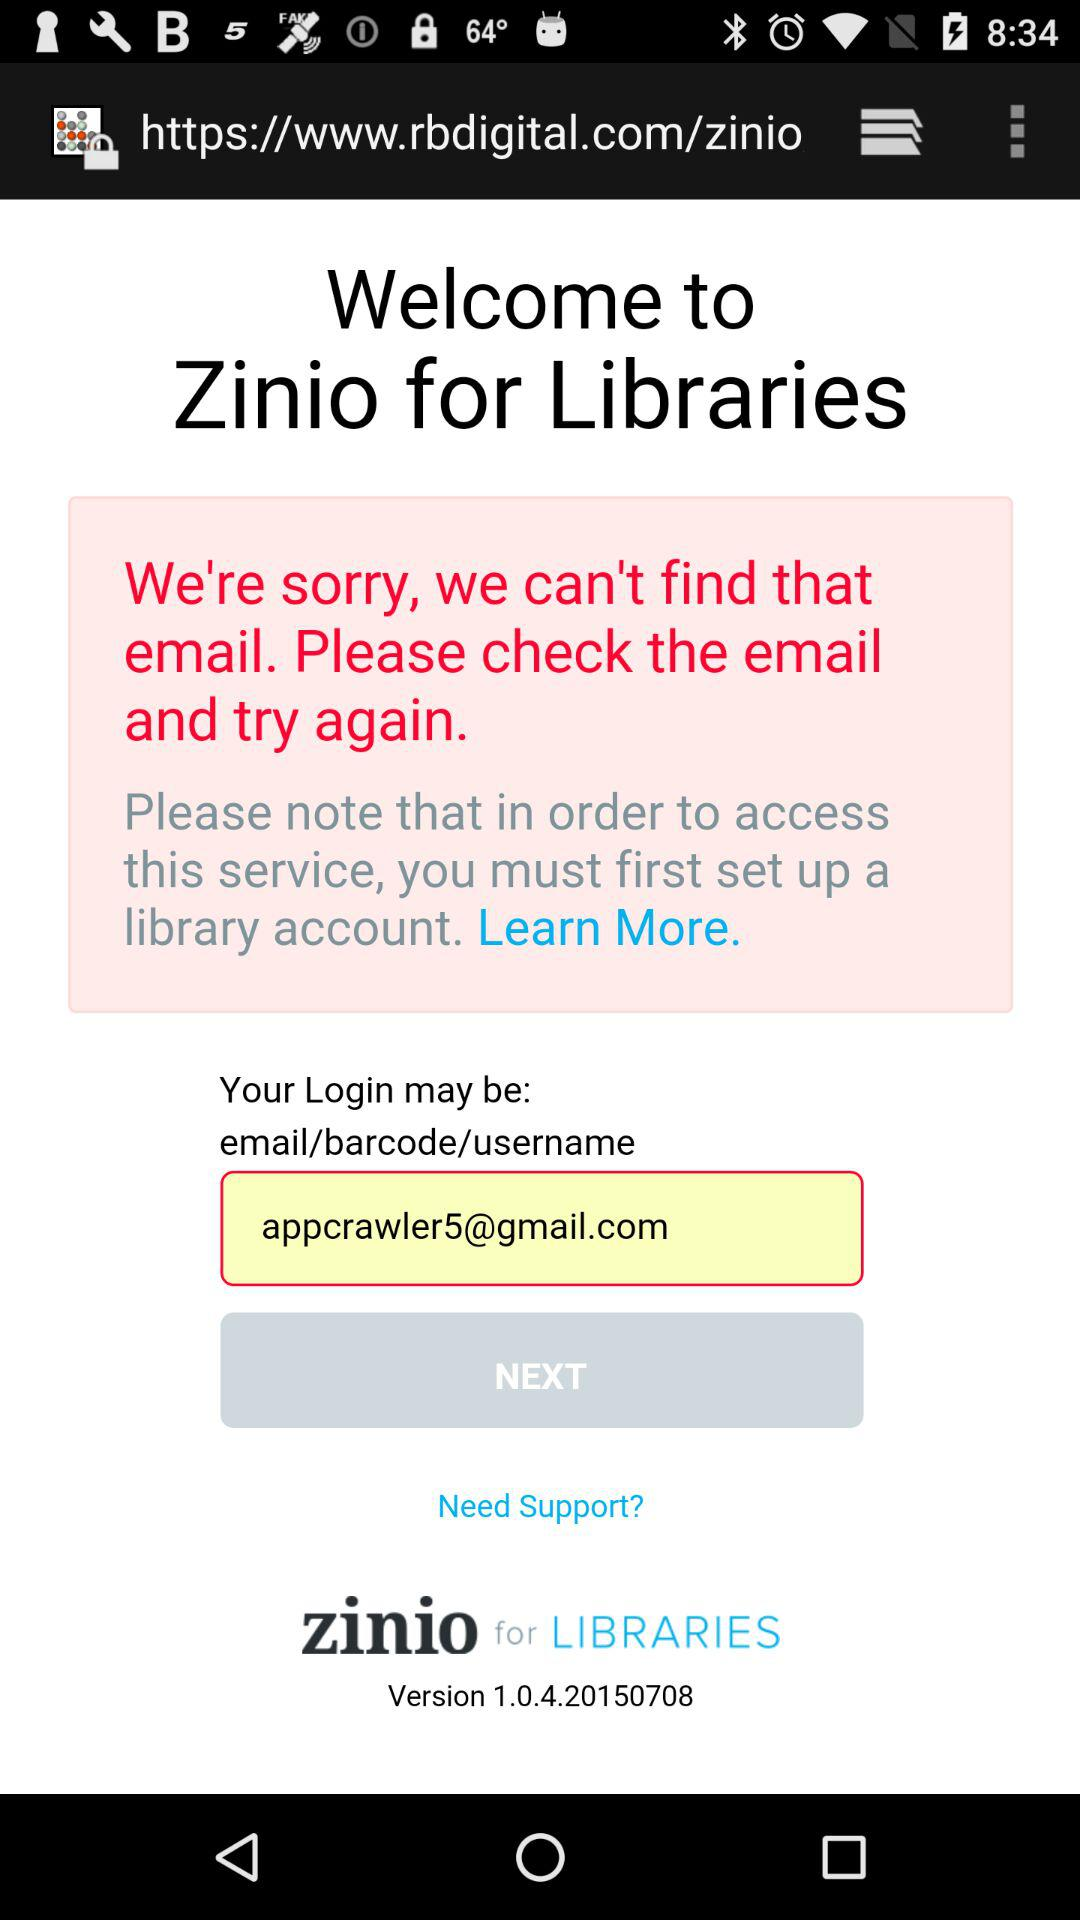What is the version of the application? The version of the application is 1.0.4.20150708. 